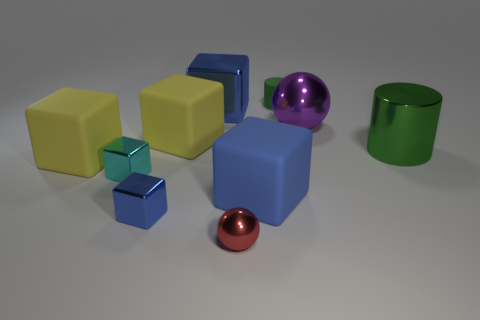Is the number of tiny blue metallic blocks less than the number of blue balls?
Provide a succinct answer. No. What material is the cylinder right of the tiny thing that is behind the purple metal ball?
Keep it short and to the point. Metal. Do the cyan block and the red metallic object have the same size?
Provide a succinct answer. Yes. How many things are brown spheres or big green metallic cylinders?
Make the answer very short. 1. What size is the rubber object that is behind the large green thing and in front of the tiny green rubber thing?
Your response must be concise. Large. Is the number of red balls behind the tiny red object less than the number of rubber spheres?
Ensure brevity in your answer.  No. What is the shape of the tiny cyan thing that is the same material as the purple sphere?
Offer a terse response. Cube. Do the shiny object that is right of the big purple metallic ball and the tiny green object right of the tiny blue thing have the same shape?
Provide a short and direct response. Yes. Are there fewer spheres that are on the right side of the tiny cyan metal object than large rubber things behind the tiny blue cube?
Offer a very short reply. Yes. The object that is the same color as the small matte cylinder is what shape?
Offer a terse response. Cylinder. 